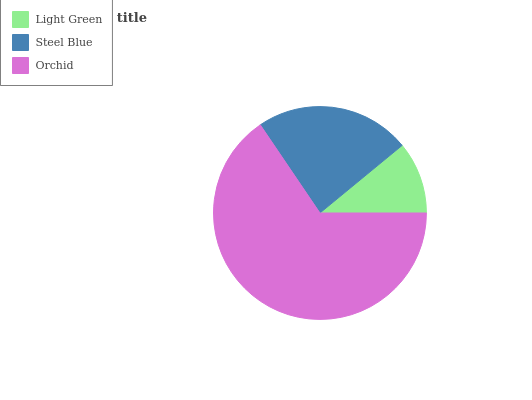Is Light Green the minimum?
Answer yes or no. Yes. Is Orchid the maximum?
Answer yes or no. Yes. Is Steel Blue the minimum?
Answer yes or no. No. Is Steel Blue the maximum?
Answer yes or no. No. Is Steel Blue greater than Light Green?
Answer yes or no. Yes. Is Light Green less than Steel Blue?
Answer yes or no. Yes. Is Light Green greater than Steel Blue?
Answer yes or no. No. Is Steel Blue less than Light Green?
Answer yes or no. No. Is Steel Blue the high median?
Answer yes or no. Yes. Is Steel Blue the low median?
Answer yes or no. Yes. Is Orchid the high median?
Answer yes or no. No. Is Orchid the low median?
Answer yes or no. No. 